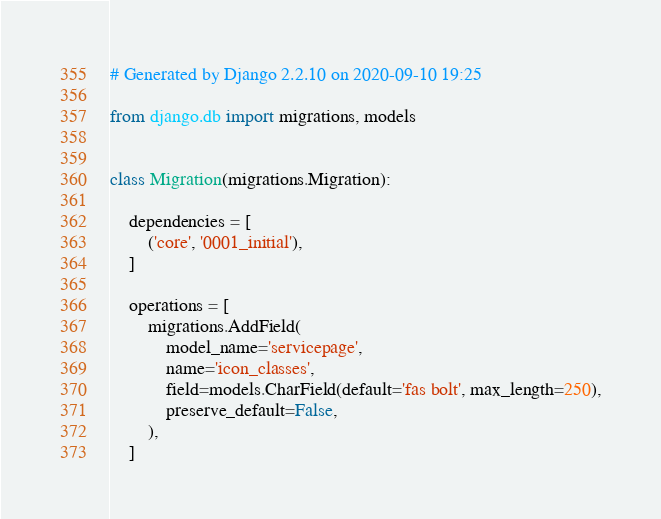<code> <loc_0><loc_0><loc_500><loc_500><_Python_># Generated by Django 2.2.10 on 2020-09-10 19:25

from django.db import migrations, models


class Migration(migrations.Migration):

    dependencies = [
        ('core', '0001_initial'),
    ]

    operations = [
        migrations.AddField(
            model_name='servicepage',
            name='icon_classes',
            field=models.CharField(default='fas bolt', max_length=250),
            preserve_default=False,
        ),
    ]
</code> 